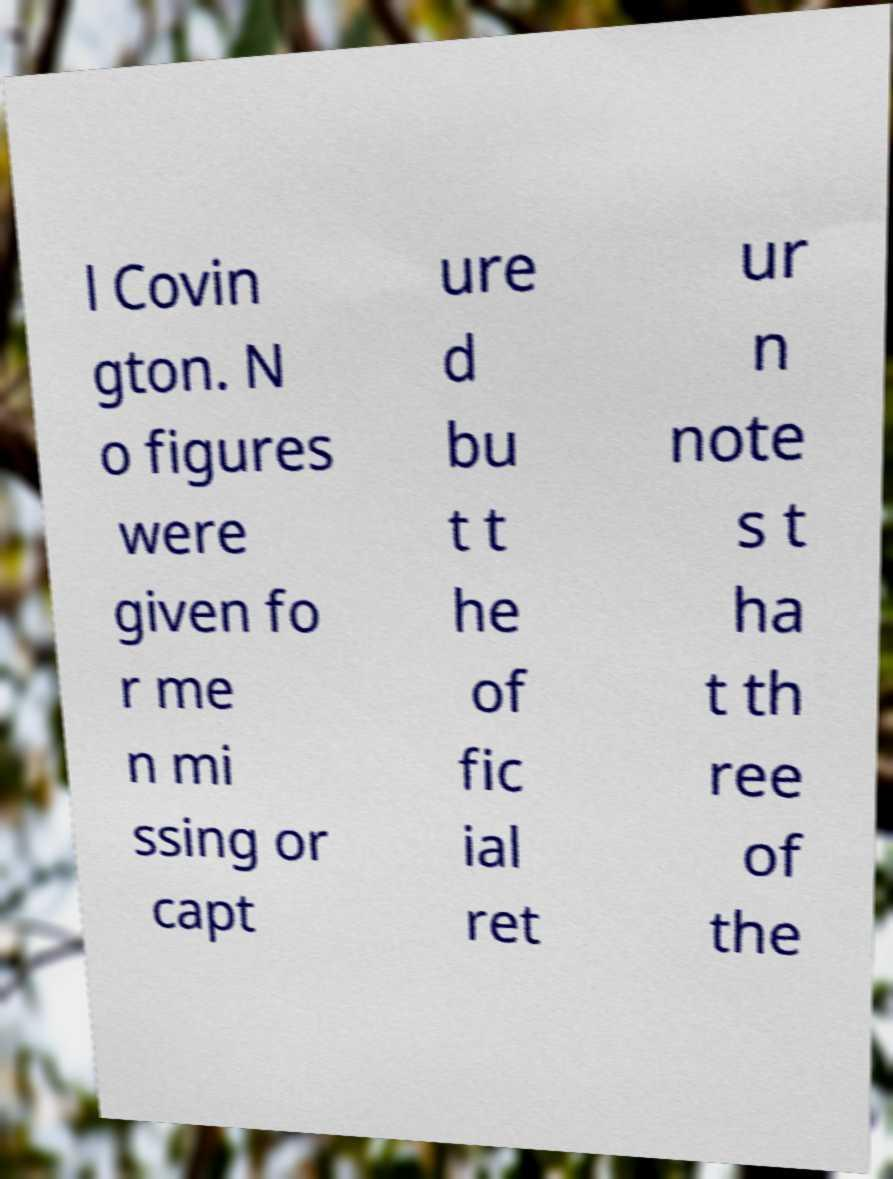Can you accurately transcribe the text from the provided image for me? l Covin gton. N o figures were given fo r me n mi ssing or capt ure d bu t t he of fic ial ret ur n note s t ha t th ree of the 